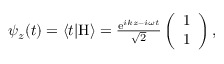Convert formula to latex. <formula><loc_0><loc_0><loc_500><loc_500>\begin{array} { r } { \psi _ { z } ( t ) = \langle t | H \rangle = \frac { e ^ { i k z - i \omega t } } { \sqrt { 2 } } \left ( \begin{array} { c } { 1 } \\ { 1 } \end{array} \right ) , } \end{array}</formula> 